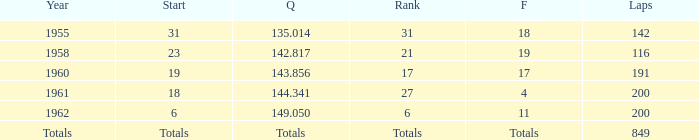What year has a finish of 19? 1958.0. 